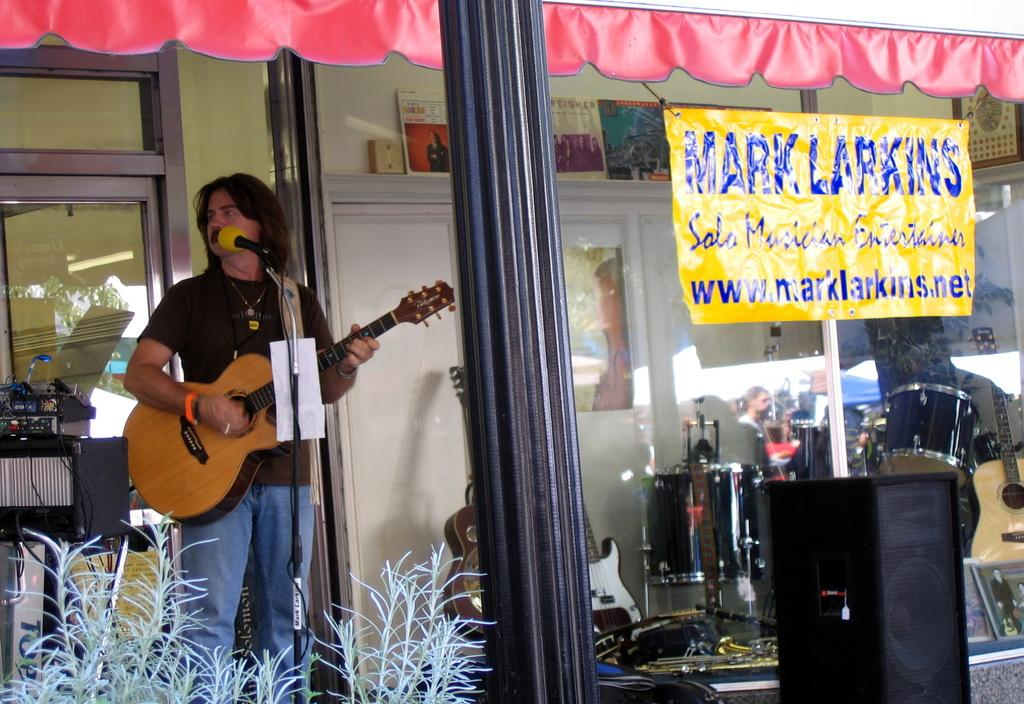What is the man in the image doing? The man is standing in front of a microphone and playing a guitar. What can be seen through the glass in the image? Musical instruments are visible through the glass. What is hanging on the wall in the image? There is a poster in the image. What type of vegetation is present in the image? There is a plant in the image. What type of circle is being used to drink soda in the image? There is no circle or soda present in the image. 